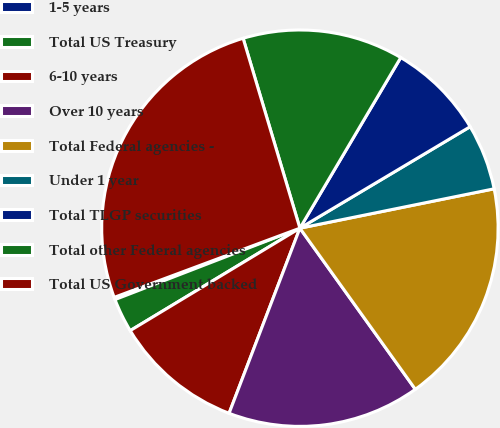<chart> <loc_0><loc_0><loc_500><loc_500><pie_chart><fcel>1-5 years<fcel>Total US Treasury<fcel>6-10 years<fcel>Over 10 years<fcel>Total Federal agencies -<fcel>Under 1 year<fcel>Total TLGP securities<fcel>Total other Federal agencies<fcel>Total US Government backed<nl><fcel>0.19%<fcel>2.78%<fcel>10.54%<fcel>15.71%<fcel>18.29%<fcel>5.37%<fcel>7.95%<fcel>13.12%<fcel>26.05%<nl></chart> 